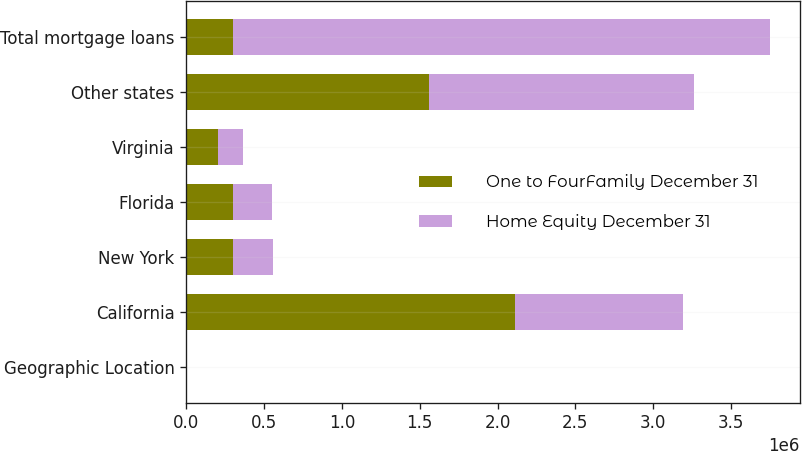Convert chart to OTSL. <chart><loc_0><loc_0><loc_500><loc_500><stacked_bar_chart><ecel><fcel>Geographic Location<fcel>California<fcel>New York<fcel>Florida<fcel>Virginia<fcel>Other states<fcel>Total mortgage loans<nl><fcel>One to FourFamily December 31<fcel>2013<fcel>2.11126e+06<fcel>300536<fcel>300435<fcel>205483<fcel>1.55708e+06<fcel>300435<nl><fcel>Home Equity December 31<fcel>2013<fcel>1.08286e+06<fcel>259331<fcel>246980<fcel>157721<fcel>1.70706e+06<fcel>3.45396e+06<nl></chart> 